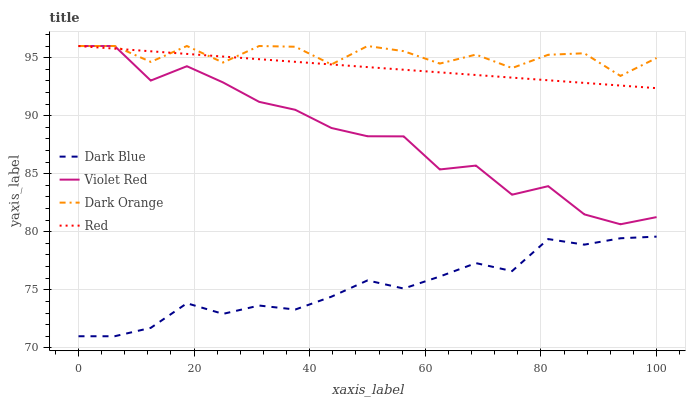Does Dark Blue have the minimum area under the curve?
Answer yes or no. Yes. Does Dark Orange have the maximum area under the curve?
Answer yes or no. Yes. Does Violet Red have the minimum area under the curve?
Answer yes or no. No. Does Violet Red have the maximum area under the curve?
Answer yes or no. No. Is Red the smoothest?
Answer yes or no. Yes. Is Violet Red the roughest?
Answer yes or no. Yes. Is Violet Red the smoothest?
Answer yes or no. No. Is Red the roughest?
Answer yes or no. No. Does Dark Blue have the lowest value?
Answer yes or no. Yes. Does Violet Red have the lowest value?
Answer yes or no. No. Does Dark Orange have the highest value?
Answer yes or no. Yes. Is Dark Blue less than Dark Orange?
Answer yes or no. Yes. Is Dark Orange greater than Dark Blue?
Answer yes or no. Yes. Does Dark Orange intersect Violet Red?
Answer yes or no. Yes. Is Dark Orange less than Violet Red?
Answer yes or no. No. Is Dark Orange greater than Violet Red?
Answer yes or no. No. Does Dark Blue intersect Dark Orange?
Answer yes or no. No. 